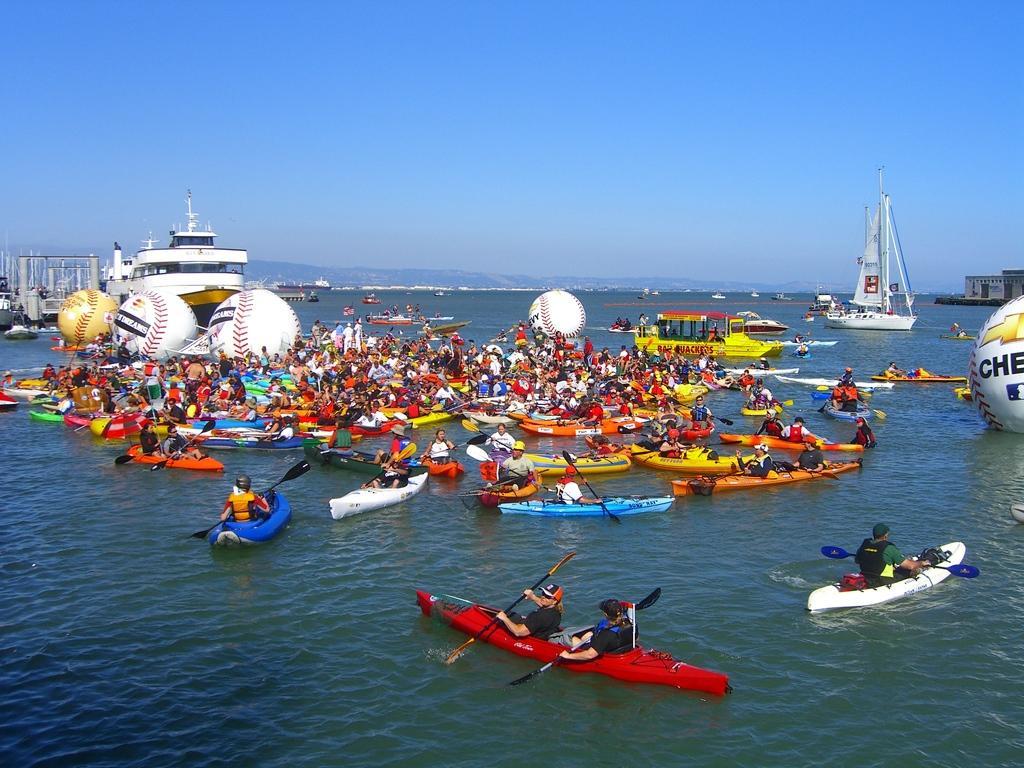In one or two sentences, can you explain what this image depicts? In this image I see number of boats on which there are people sitting on it and I see most of them are holding paddles in their hands and I see the water. In the background I see the sky which is of blue in color. 